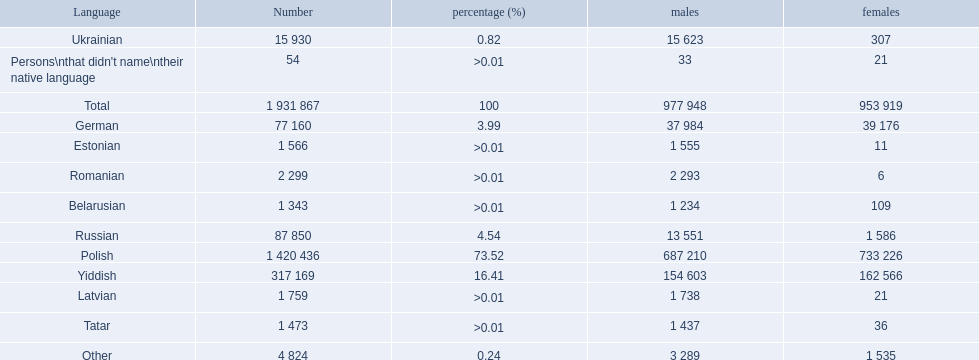Which languages are spoken by more than 50,000 people? Polish, Yiddish, Russian, German. Of these languages, which ones are spoken by less than 15% of the population? Russian, German. Of the remaining two, which one is spoken by 37,984 males? German. 